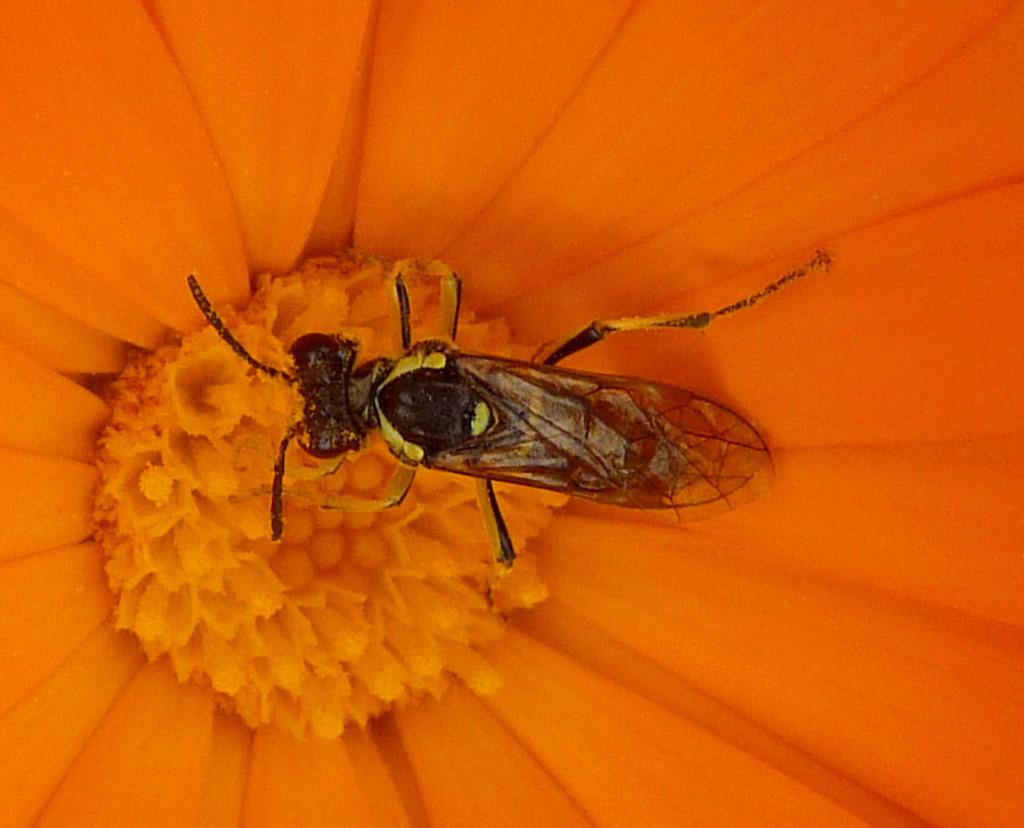What is present on the orange flower in the image? There is an insect on the orange flower in the image. Can you describe the insect's location on the flower? The insect is on the orange flower. How many zebras are sleeping on the orange flower in the image? There are no zebras present in the image, and the image does not depict any sleeping animals. 